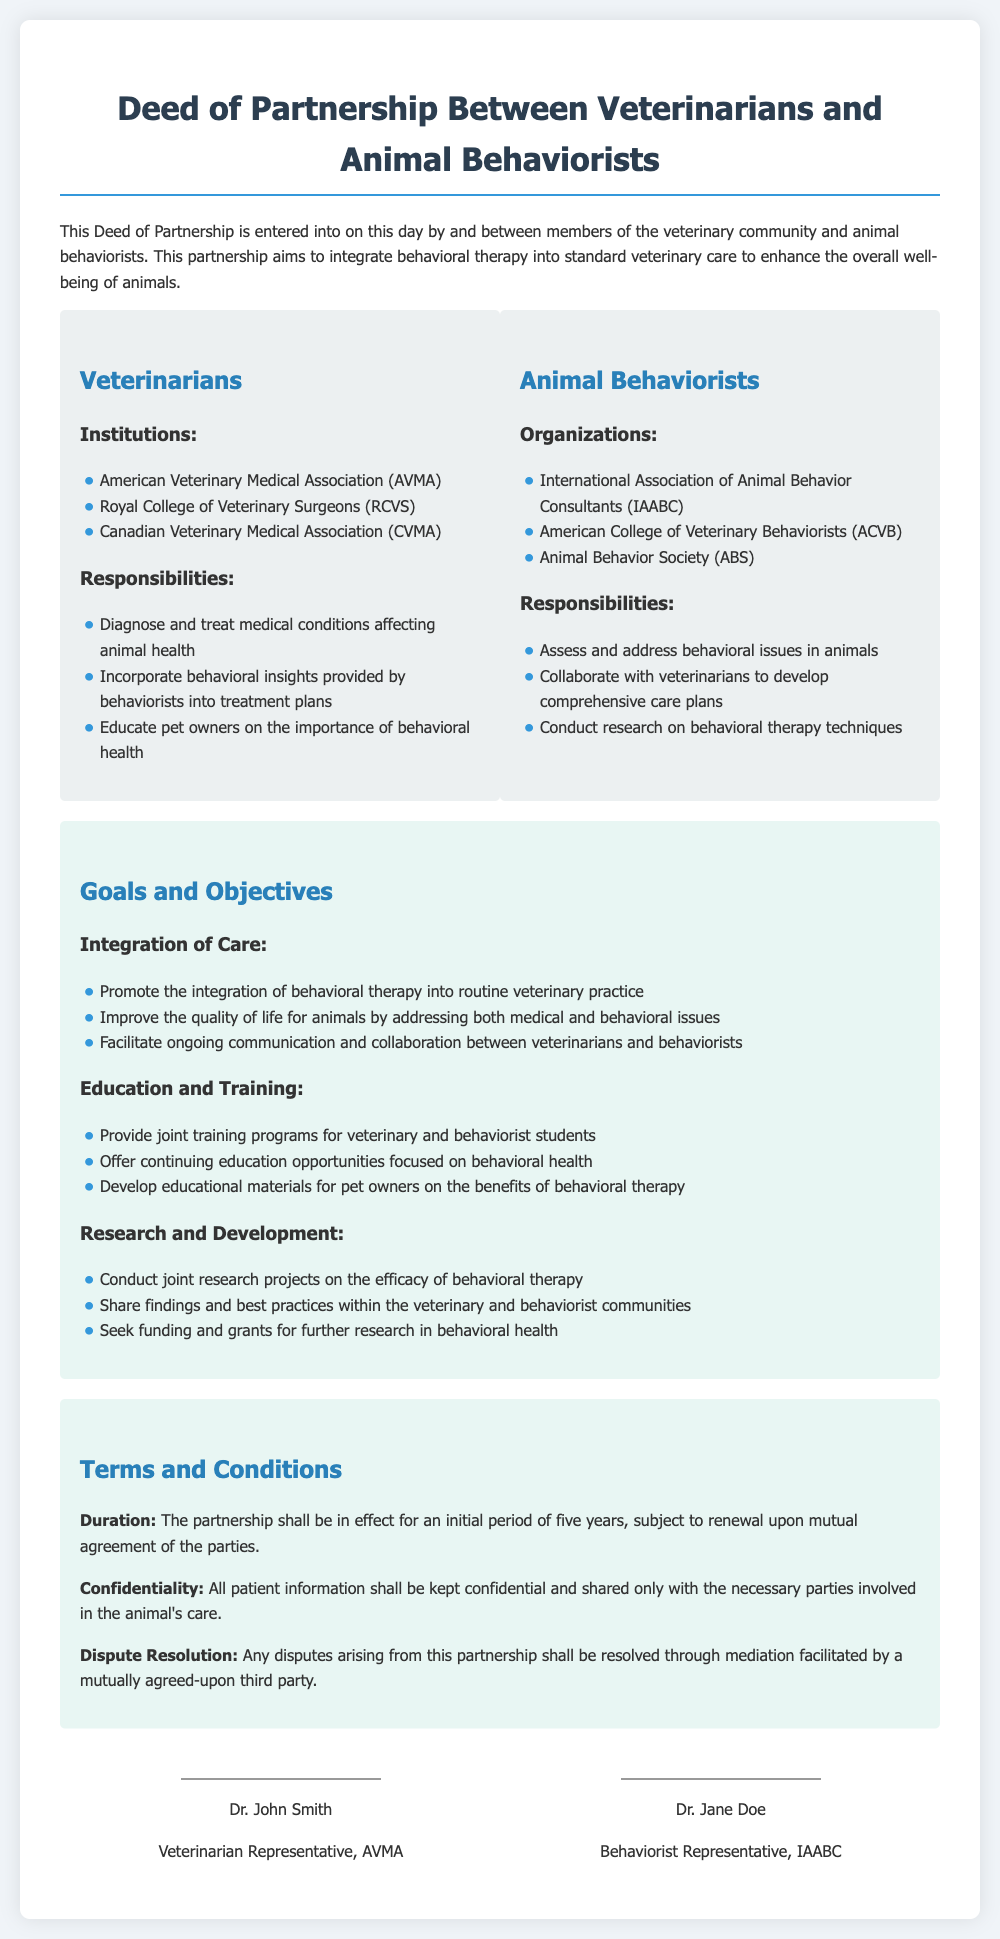What is the title of the document? The title is prominently displayed at the top of the document.
Answer: Deed of Partnership Between Veterinarians and Animal Behaviorists How many organizations are listed under Veterinarians? The number of organizations can be found in the list provided in the Veterinarians section.
Answer: 3 What is one of the responsibilities of Animal Behaviorists? The responsibilities are listed in the Animal Behaviorists section of the document.
Answer: Assess and address behavioral issues in animals What is the term of the partnership? The duration of the partnership is specified in the Terms and Conditions section.
Answer: Five years What type of training programs will be offered? This information is found under the Education and Training goals in the document.
Answer: Joint training programs How will disputes be resolved? The method for dispute resolution is detailed in the Terms and Conditions.
Answer: Mediation Who represents the AVMA? The representative from AVMA is mentioned in the signatures section.
Answer: Dr. John Smith What is the main goal of this partnership? The main goal is summarized in the introduction of the document.
Answer: Integrate behavioral therapy into standard veterinary care 